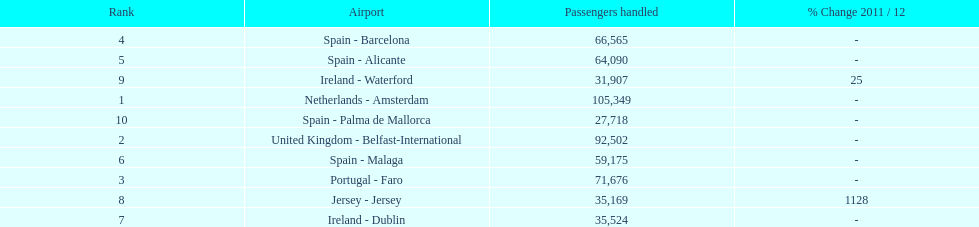How many airports are listed? 10. 